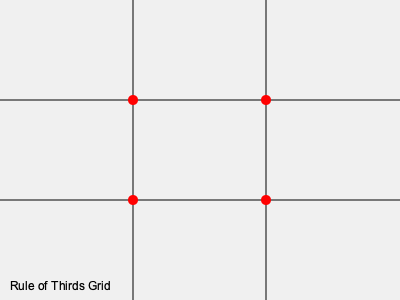As a professional photographer, you're asked to explain the rule of thirds to a group of students. Using the grid overlay provided, which points are considered the most visually impactful for placing key elements in a photograph? 1. The rule of thirds is a fundamental principle in photographic composition.

2. To apply this rule, we mentally divide the image into a 3x3 grid, creating nine equal parts.

3. The grid is represented in the diagram by two horizontal and two vertical lines.

4. The rule of thirds suggests that important compositional elements should be placed along these lines or at their intersections.

5. The intersections of these lines create four points, marked in red on the diagram.

6. These four intersection points are considered the most visually impactful areas in the frame.

7. Placing key elements of the photograph at or near these points can create a more balanced and aesthetically pleasing composition.

8. This technique often results in more dynamic and interesting images compared to simply centering the subject.

9. While the rule of thirds is a useful guideline, it's not an absolute rule. Experienced photographers often use it as a starting point and may deviate from it for creative purposes.

10. The effectiveness of this rule is based on the theory that the human eye naturally gravitates towards these intersection points when viewing an image.
Answer: The four intersection points of the grid lines 